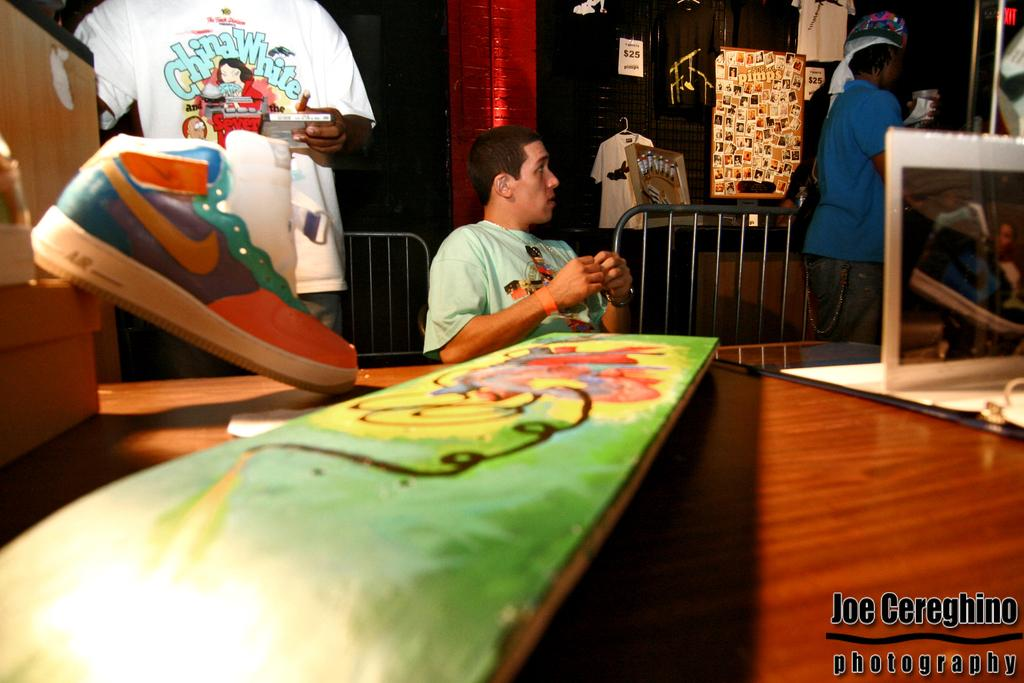<image>
Share a concise interpretation of the image provided. A nike sneaker is on top of a table as displayed in this photo by Joe Cereghino. 